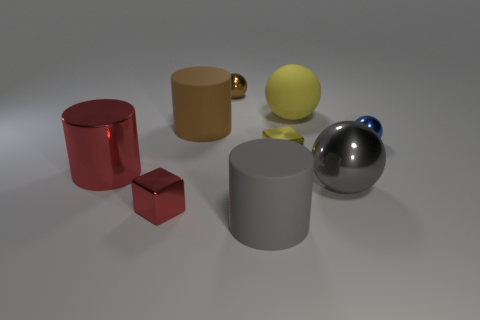Subtract all big rubber cylinders. How many cylinders are left? 1 Subtract all red cylinders. How many cylinders are left? 2 Subtract 3 cylinders. How many cylinders are left? 0 Subtract 1 red cylinders. How many objects are left? 8 Subtract all spheres. How many objects are left? 5 Subtract all cyan cubes. Subtract all green balls. How many cubes are left? 2 Subtract all cyan balls. How many yellow blocks are left? 1 Subtract all small red rubber cubes. Subtract all blocks. How many objects are left? 7 Add 4 large red objects. How many large red objects are left? 5 Add 6 brown matte cylinders. How many brown matte cylinders exist? 7 